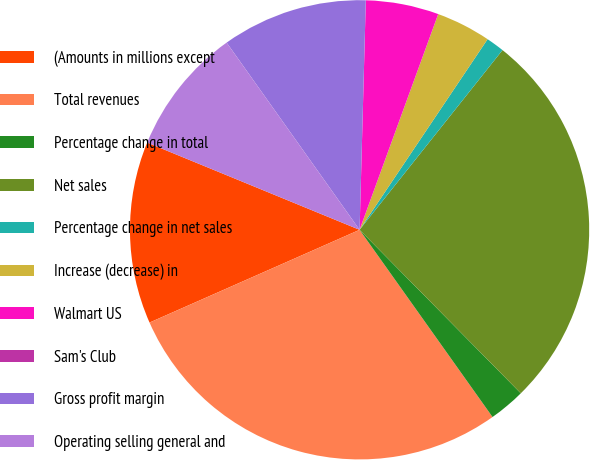Convert chart to OTSL. <chart><loc_0><loc_0><loc_500><loc_500><pie_chart><fcel>(Amounts in millions except<fcel>Total revenues<fcel>Percentage change in total<fcel>Net sales<fcel>Percentage change in net sales<fcel>Increase (decrease) in<fcel>Walmart US<fcel>Sam's Club<fcel>Gross profit margin<fcel>Operating selling general and<nl><fcel>12.82%<fcel>28.21%<fcel>2.56%<fcel>26.92%<fcel>1.28%<fcel>3.85%<fcel>5.13%<fcel>0.0%<fcel>10.26%<fcel>8.97%<nl></chart> 